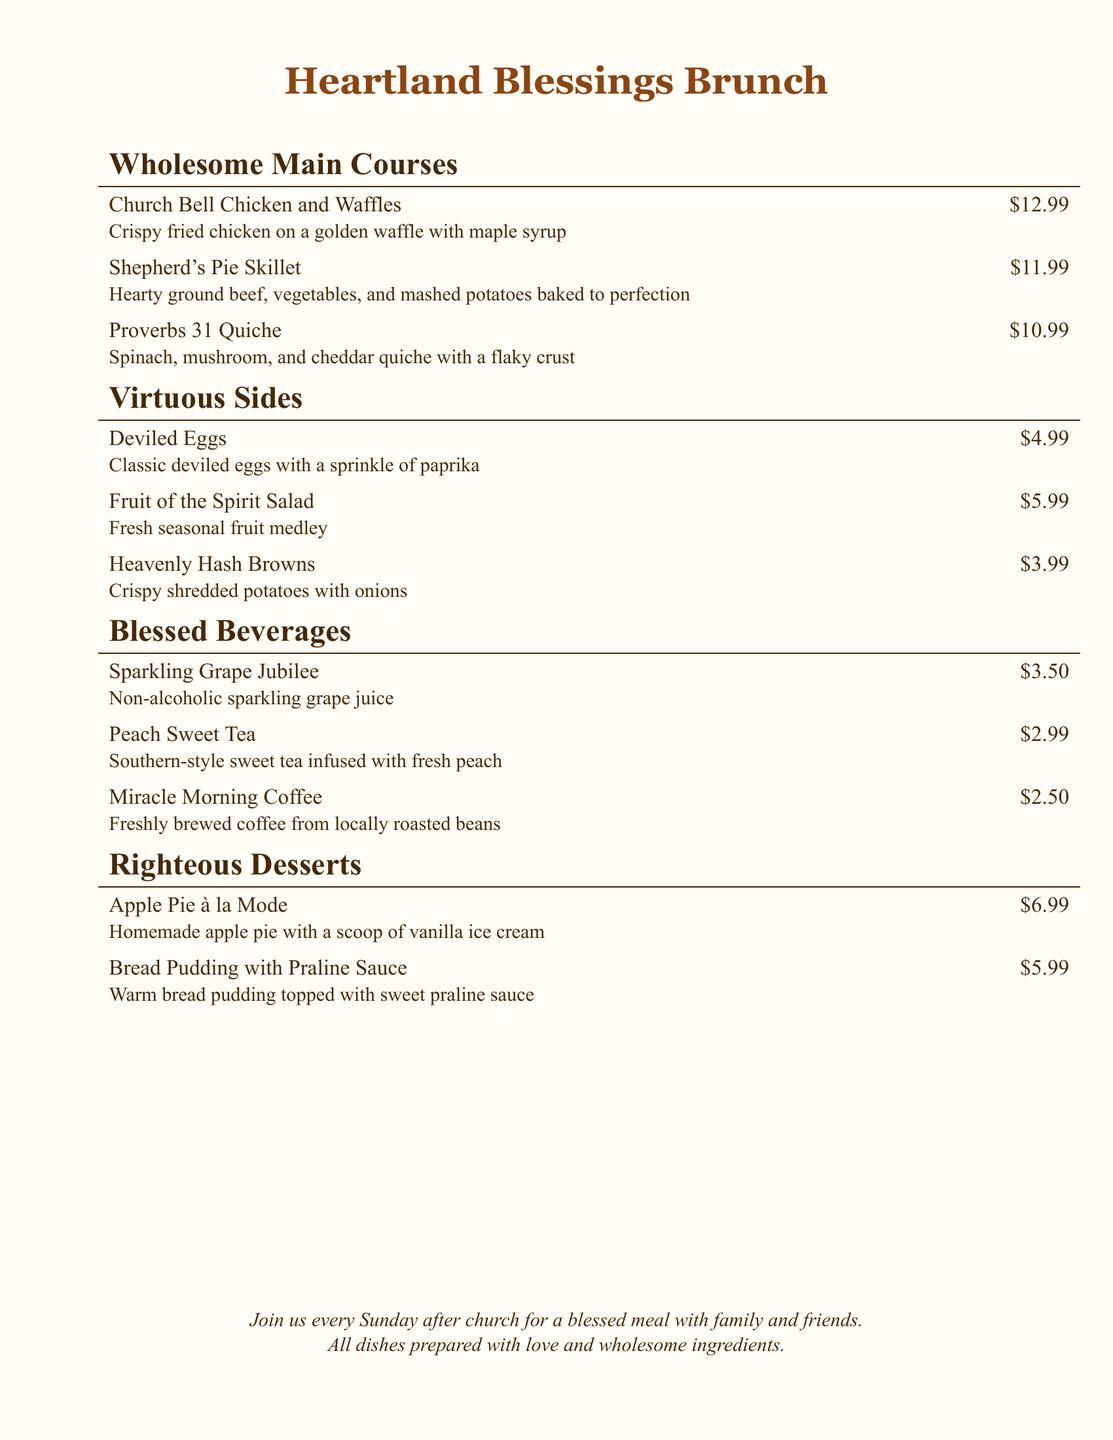What is the name of the brunch menu? The name of the menu is stated at the top of the document.
Answer: Heartland Blessings Brunch How much does the Shepherd's Pie Skillet cost? The cost of the Shepherd's Pie Skillet is listed in the main courses section.
Answer: $11.99 What beverage is described as being infused with fresh peach? This beverage's description specifically mentions peach infusion in the beverages section.
Answer: Peach Sweet Tea What is included in the Proverbs 31 Quiche? The ingredients of the quiche are mentioned in the description of the dish.
Answer: Spinach, mushroom, and cheddar How many desserts are listed on the menu? The number of desserts can be counted from the desserts section of the menu.
Answer: 2 Which side dish is priced at $4.99? The price of each side dish is listed, and this can be found in the sides section.
Answer: Deviled Eggs What type of coffee is offered on the brunch menu? The description of the coffee specifies its type in the beverages section.
Answer: Miracle Morning Coffee Which dish involves baked ground beef and vegetables? The name of the dish that involves these ingredients is stated in the main courses section.
Answer: Shepherd's Pie Skillet What is the price of the Apple Pie à la Mode? The cost is indicated in the desserts section of the menu.
Answer: $6.99 